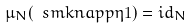Convert formula to latex. <formula><loc_0><loc_0><loc_500><loc_500>\mu _ { N } ( \ s m k n a p p { \eta } { 1 } ) = i d _ { N }</formula> 